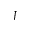<formula> <loc_0><loc_0><loc_500><loc_500>J</formula> 